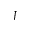<formula> <loc_0><loc_0><loc_500><loc_500>J</formula> 